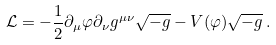Convert formula to latex. <formula><loc_0><loc_0><loc_500><loc_500>\mathcal { L } = - \frac { 1 } { 2 } \partial _ { \mu } \varphi \partial _ { \nu } g ^ { \mu \nu } \sqrt { - g } - V ( \varphi ) \sqrt { - g } \, .</formula> 